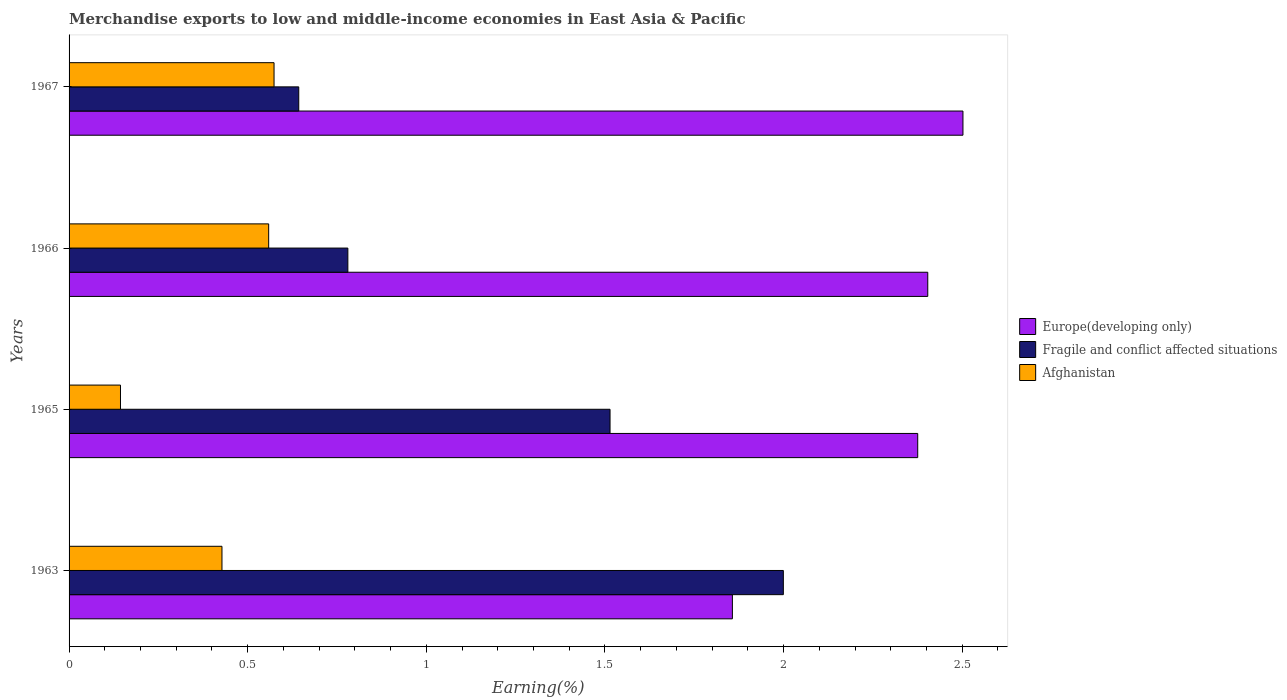How many different coloured bars are there?
Your answer should be very brief. 3. How many groups of bars are there?
Your answer should be compact. 4. Are the number of bars per tick equal to the number of legend labels?
Your response must be concise. Yes. How many bars are there on the 1st tick from the bottom?
Keep it short and to the point. 3. What is the label of the 3rd group of bars from the top?
Give a very brief answer. 1965. In how many cases, is the number of bars for a given year not equal to the number of legend labels?
Make the answer very short. 0. What is the percentage of amount earned from merchandise exports in Afghanistan in 1967?
Your response must be concise. 0.57. Across all years, what is the maximum percentage of amount earned from merchandise exports in Afghanistan?
Your answer should be very brief. 0.57. Across all years, what is the minimum percentage of amount earned from merchandise exports in Afghanistan?
Provide a short and direct response. 0.14. In which year was the percentage of amount earned from merchandise exports in Europe(developing only) maximum?
Your answer should be very brief. 1967. In which year was the percentage of amount earned from merchandise exports in Afghanistan minimum?
Give a very brief answer. 1965. What is the total percentage of amount earned from merchandise exports in Afghanistan in the graph?
Give a very brief answer. 1.7. What is the difference between the percentage of amount earned from merchandise exports in Europe(developing only) in 1963 and that in 1965?
Make the answer very short. -0.52. What is the difference between the percentage of amount earned from merchandise exports in Europe(developing only) in 1966 and the percentage of amount earned from merchandise exports in Afghanistan in 1967?
Your answer should be compact. 1.83. What is the average percentage of amount earned from merchandise exports in Europe(developing only) per year?
Give a very brief answer. 2.28. In the year 1967, what is the difference between the percentage of amount earned from merchandise exports in Afghanistan and percentage of amount earned from merchandise exports in Europe(developing only)?
Your response must be concise. -1.93. What is the ratio of the percentage of amount earned from merchandise exports in Fragile and conflict affected situations in 1966 to that in 1967?
Offer a terse response. 1.21. Is the percentage of amount earned from merchandise exports in Fragile and conflict affected situations in 1965 less than that in 1966?
Your response must be concise. No. Is the difference between the percentage of amount earned from merchandise exports in Afghanistan in 1965 and 1967 greater than the difference between the percentage of amount earned from merchandise exports in Europe(developing only) in 1965 and 1967?
Provide a short and direct response. No. What is the difference between the highest and the second highest percentage of amount earned from merchandise exports in Fragile and conflict affected situations?
Offer a terse response. 0.49. What is the difference between the highest and the lowest percentage of amount earned from merchandise exports in Fragile and conflict affected situations?
Offer a very short reply. 1.36. What does the 2nd bar from the top in 1965 represents?
Offer a very short reply. Fragile and conflict affected situations. What does the 1st bar from the bottom in 1965 represents?
Make the answer very short. Europe(developing only). Is it the case that in every year, the sum of the percentage of amount earned from merchandise exports in Afghanistan and percentage of amount earned from merchandise exports in Fragile and conflict affected situations is greater than the percentage of amount earned from merchandise exports in Europe(developing only)?
Keep it short and to the point. No. How many bars are there?
Make the answer very short. 12. How many years are there in the graph?
Make the answer very short. 4. Are the values on the major ticks of X-axis written in scientific E-notation?
Keep it short and to the point. No. Does the graph contain grids?
Your answer should be compact. No. Where does the legend appear in the graph?
Make the answer very short. Center right. How are the legend labels stacked?
Provide a succinct answer. Vertical. What is the title of the graph?
Give a very brief answer. Merchandise exports to low and middle-income economies in East Asia & Pacific. Does "Mauritania" appear as one of the legend labels in the graph?
Ensure brevity in your answer.  No. What is the label or title of the X-axis?
Provide a short and direct response. Earning(%). What is the Earning(%) in Europe(developing only) in 1963?
Your response must be concise. 1.86. What is the Earning(%) of Fragile and conflict affected situations in 1963?
Offer a terse response. 2. What is the Earning(%) of Afghanistan in 1963?
Your answer should be compact. 0.43. What is the Earning(%) in Europe(developing only) in 1965?
Give a very brief answer. 2.38. What is the Earning(%) of Fragile and conflict affected situations in 1965?
Offer a very short reply. 1.51. What is the Earning(%) in Afghanistan in 1965?
Keep it short and to the point. 0.14. What is the Earning(%) in Europe(developing only) in 1966?
Offer a very short reply. 2.4. What is the Earning(%) of Fragile and conflict affected situations in 1966?
Keep it short and to the point. 0.78. What is the Earning(%) of Afghanistan in 1966?
Give a very brief answer. 0.56. What is the Earning(%) of Europe(developing only) in 1967?
Give a very brief answer. 2.5. What is the Earning(%) of Fragile and conflict affected situations in 1967?
Provide a short and direct response. 0.64. What is the Earning(%) in Afghanistan in 1967?
Provide a succinct answer. 0.57. Across all years, what is the maximum Earning(%) of Europe(developing only)?
Offer a terse response. 2.5. Across all years, what is the maximum Earning(%) in Fragile and conflict affected situations?
Offer a terse response. 2. Across all years, what is the maximum Earning(%) in Afghanistan?
Provide a succinct answer. 0.57. Across all years, what is the minimum Earning(%) of Europe(developing only)?
Your answer should be compact. 1.86. Across all years, what is the minimum Earning(%) in Fragile and conflict affected situations?
Provide a succinct answer. 0.64. Across all years, what is the minimum Earning(%) in Afghanistan?
Keep it short and to the point. 0.14. What is the total Earning(%) of Europe(developing only) in the graph?
Make the answer very short. 9.14. What is the total Earning(%) of Fragile and conflict affected situations in the graph?
Give a very brief answer. 4.94. What is the total Earning(%) of Afghanistan in the graph?
Keep it short and to the point. 1.7. What is the difference between the Earning(%) of Europe(developing only) in 1963 and that in 1965?
Provide a succinct answer. -0.52. What is the difference between the Earning(%) in Fragile and conflict affected situations in 1963 and that in 1965?
Make the answer very short. 0.49. What is the difference between the Earning(%) in Afghanistan in 1963 and that in 1965?
Your answer should be compact. 0.28. What is the difference between the Earning(%) of Europe(developing only) in 1963 and that in 1966?
Your response must be concise. -0.55. What is the difference between the Earning(%) in Fragile and conflict affected situations in 1963 and that in 1966?
Your response must be concise. 1.22. What is the difference between the Earning(%) of Afghanistan in 1963 and that in 1966?
Give a very brief answer. -0.13. What is the difference between the Earning(%) in Europe(developing only) in 1963 and that in 1967?
Your response must be concise. -0.65. What is the difference between the Earning(%) of Fragile and conflict affected situations in 1963 and that in 1967?
Give a very brief answer. 1.36. What is the difference between the Earning(%) of Afghanistan in 1963 and that in 1967?
Keep it short and to the point. -0.15. What is the difference between the Earning(%) of Europe(developing only) in 1965 and that in 1966?
Ensure brevity in your answer.  -0.03. What is the difference between the Earning(%) of Fragile and conflict affected situations in 1965 and that in 1966?
Offer a very short reply. 0.73. What is the difference between the Earning(%) of Afghanistan in 1965 and that in 1966?
Ensure brevity in your answer.  -0.41. What is the difference between the Earning(%) in Europe(developing only) in 1965 and that in 1967?
Your response must be concise. -0.13. What is the difference between the Earning(%) of Fragile and conflict affected situations in 1965 and that in 1967?
Your response must be concise. 0.87. What is the difference between the Earning(%) of Afghanistan in 1965 and that in 1967?
Your answer should be compact. -0.43. What is the difference between the Earning(%) in Europe(developing only) in 1966 and that in 1967?
Offer a very short reply. -0.1. What is the difference between the Earning(%) in Fragile and conflict affected situations in 1966 and that in 1967?
Your answer should be compact. 0.14. What is the difference between the Earning(%) of Afghanistan in 1966 and that in 1967?
Provide a short and direct response. -0.02. What is the difference between the Earning(%) in Europe(developing only) in 1963 and the Earning(%) in Fragile and conflict affected situations in 1965?
Your response must be concise. 0.34. What is the difference between the Earning(%) of Europe(developing only) in 1963 and the Earning(%) of Afghanistan in 1965?
Make the answer very short. 1.71. What is the difference between the Earning(%) of Fragile and conflict affected situations in 1963 and the Earning(%) of Afghanistan in 1965?
Offer a terse response. 1.86. What is the difference between the Earning(%) of Europe(developing only) in 1963 and the Earning(%) of Fragile and conflict affected situations in 1966?
Offer a very short reply. 1.08. What is the difference between the Earning(%) of Europe(developing only) in 1963 and the Earning(%) of Afghanistan in 1966?
Your response must be concise. 1.3. What is the difference between the Earning(%) in Fragile and conflict affected situations in 1963 and the Earning(%) in Afghanistan in 1966?
Ensure brevity in your answer.  1.44. What is the difference between the Earning(%) in Europe(developing only) in 1963 and the Earning(%) in Fragile and conflict affected situations in 1967?
Offer a terse response. 1.21. What is the difference between the Earning(%) of Europe(developing only) in 1963 and the Earning(%) of Afghanistan in 1967?
Ensure brevity in your answer.  1.28. What is the difference between the Earning(%) in Fragile and conflict affected situations in 1963 and the Earning(%) in Afghanistan in 1967?
Keep it short and to the point. 1.43. What is the difference between the Earning(%) of Europe(developing only) in 1965 and the Earning(%) of Fragile and conflict affected situations in 1966?
Your answer should be compact. 1.59. What is the difference between the Earning(%) in Europe(developing only) in 1965 and the Earning(%) in Afghanistan in 1966?
Keep it short and to the point. 1.82. What is the difference between the Earning(%) of Fragile and conflict affected situations in 1965 and the Earning(%) of Afghanistan in 1966?
Provide a succinct answer. 0.96. What is the difference between the Earning(%) of Europe(developing only) in 1965 and the Earning(%) of Fragile and conflict affected situations in 1967?
Offer a very short reply. 1.73. What is the difference between the Earning(%) in Europe(developing only) in 1965 and the Earning(%) in Afghanistan in 1967?
Offer a very short reply. 1.8. What is the difference between the Earning(%) of Fragile and conflict affected situations in 1965 and the Earning(%) of Afghanistan in 1967?
Your answer should be very brief. 0.94. What is the difference between the Earning(%) of Europe(developing only) in 1966 and the Earning(%) of Fragile and conflict affected situations in 1967?
Give a very brief answer. 1.76. What is the difference between the Earning(%) in Europe(developing only) in 1966 and the Earning(%) in Afghanistan in 1967?
Ensure brevity in your answer.  1.83. What is the difference between the Earning(%) in Fragile and conflict affected situations in 1966 and the Earning(%) in Afghanistan in 1967?
Give a very brief answer. 0.21. What is the average Earning(%) in Europe(developing only) per year?
Your response must be concise. 2.28. What is the average Earning(%) in Fragile and conflict affected situations per year?
Provide a succinct answer. 1.23. What is the average Earning(%) in Afghanistan per year?
Offer a terse response. 0.43. In the year 1963, what is the difference between the Earning(%) in Europe(developing only) and Earning(%) in Fragile and conflict affected situations?
Give a very brief answer. -0.14. In the year 1963, what is the difference between the Earning(%) in Europe(developing only) and Earning(%) in Afghanistan?
Your response must be concise. 1.43. In the year 1963, what is the difference between the Earning(%) in Fragile and conflict affected situations and Earning(%) in Afghanistan?
Give a very brief answer. 1.57. In the year 1965, what is the difference between the Earning(%) in Europe(developing only) and Earning(%) in Fragile and conflict affected situations?
Make the answer very short. 0.86. In the year 1965, what is the difference between the Earning(%) in Europe(developing only) and Earning(%) in Afghanistan?
Make the answer very short. 2.23. In the year 1965, what is the difference between the Earning(%) in Fragile and conflict affected situations and Earning(%) in Afghanistan?
Ensure brevity in your answer.  1.37. In the year 1966, what is the difference between the Earning(%) of Europe(developing only) and Earning(%) of Fragile and conflict affected situations?
Your answer should be compact. 1.62. In the year 1966, what is the difference between the Earning(%) of Europe(developing only) and Earning(%) of Afghanistan?
Give a very brief answer. 1.84. In the year 1966, what is the difference between the Earning(%) of Fragile and conflict affected situations and Earning(%) of Afghanistan?
Provide a short and direct response. 0.22. In the year 1967, what is the difference between the Earning(%) in Europe(developing only) and Earning(%) in Fragile and conflict affected situations?
Your response must be concise. 1.86. In the year 1967, what is the difference between the Earning(%) in Europe(developing only) and Earning(%) in Afghanistan?
Offer a very short reply. 1.93. In the year 1967, what is the difference between the Earning(%) in Fragile and conflict affected situations and Earning(%) in Afghanistan?
Provide a short and direct response. 0.07. What is the ratio of the Earning(%) of Europe(developing only) in 1963 to that in 1965?
Your answer should be very brief. 0.78. What is the ratio of the Earning(%) in Fragile and conflict affected situations in 1963 to that in 1965?
Your answer should be compact. 1.32. What is the ratio of the Earning(%) in Afghanistan in 1963 to that in 1965?
Ensure brevity in your answer.  2.97. What is the ratio of the Earning(%) in Europe(developing only) in 1963 to that in 1966?
Offer a terse response. 0.77. What is the ratio of the Earning(%) of Fragile and conflict affected situations in 1963 to that in 1966?
Offer a terse response. 2.56. What is the ratio of the Earning(%) in Afghanistan in 1963 to that in 1966?
Provide a succinct answer. 0.77. What is the ratio of the Earning(%) of Europe(developing only) in 1963 to that in 1967?
Your response must be concise. 0.74. What is the ratio of the Earning(%) in Fragile and conflict affected situations in 1963 to that in 1967?
Your answer should be compact. 3.11. What is the ratio of the Earning(%) of Afghanistan in 1963 to that in 1967?
Your answer should be very brief. 0.75. What is the ratio of the Earning(%) of Europe(developing only) in 1965 to that in 1966?
Ensure brevity in your answer.  0.99. What is the ratio of the Earning(%) of Fragile and conflict affected situations in 1965 to that in 1966?
Offer a very short reply. 1.94. What is the ratio of the Earning(%) of Afghanistan in 1965 to that in 1966?
Your response must be concise. 0.26. What is the ratio of the Earning(%) in Europe(developing only) in 1965 to that in 1967?
Your answer should be compact. 0.95. What is the ratio of the Earning(%) of Fragile and conflict affected situations in 1965 to that in 1967?
Your answer should be very brief. 2.36. What is the ratio of the Earning(%) of Afghanistan in 1965 to that in 1967?
Your answer should be compact. 0.25. What is the ratio of the Earning(%) in Europe(developing only) in 1966 to that in 1967?
Ensure brevity in your answer.  0.96. What is the ratio of the Earning(%) of Fragile and conflict affected situations in 1966 to that in 1967?
Offer a terse response. 1.21. What is the ratio of the Earning(%) in Afghanistan in 1966 to that in 1967?
Keep it short and to the point. 0.97. What is the difference between the highest and the second highest Earning(%) in Europe(developing only)?
Your answer should be compact. 0.1. What is the difference between the highest and the second highest Earning(%) of Fragile and conflict affected situations?
Provide a short and direct response. 0.49. What is the difference between the highest and the second highest Earning(%) in Afghanistan?
Ensure brevity in your answer.  0.02. What is the difference between the highest and the lowest Earning(%) in Europe(developing only)?
Offer a very short reply. 0.65. What is the difference between the highest and the lowest Earning(%) of Fragile and conflict affected situations?
Offer a terse response. 1.36. What is the difference between the highest and the lowest Earning(%) of Afghanistan?
Give a very brief answer. 0.43. 